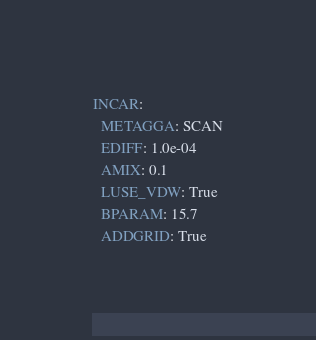<code> <loc_0><loc_0><loc_500><loc_500><_YAML_>INCAR:
  METAGGA: SCAN
  EDIFF: 1.0e-04
  AMIX: 0.1
  LUSE_VDW: True
  BPARAM: 15.7
  ADDGRID: True</code> 